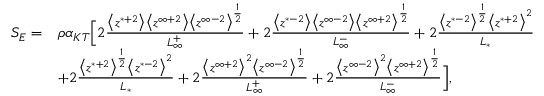<formula> <loc_0><loc_0><loc_500><loc_500>\begin{array} { r l } { S _ { E } = } & { \rho \alpha _ { K T } \left [ 2 \frac { \Big < z ^ { * + 2 } \Big > \Big < z ^ { \infty + 2 } \Big > \Big < z ^ { \infty - 2 } \Big > ^ { \frac { 1 } { 2 } } } { L _ { \infty } ^ { + } } + 2 \frac { \Big < z ^ { * - 2 } \Big > \Big < z ^ { \infty - 2 } \Big > \Big < z ^ { \infty + 2 } \Big > ^ { \frac { 1 } { 2 } } } { L _ { \infty } ^ { - } } + 2 \frac { \Big < z ^ { * - 2 } \Big > ^ { \frac { 1 } { 2 } } \Big < z ^ { * + 2 } \Big > ^ { 2 } } { L _ { * } } } \\ & { + 2 \frac { \Big < z ^ { * + 2 } \Big > ^ { \frac { 1 } { 2 } } \Big < z ^ { * - 2 } \Big > ^ { 2 } } { L _ { * } } + 2 \frac { \Big < z ^ { \infty + 2 } \Big > ^ { 2 } \Big < z ^ { \infty - 2 } \Big > ^ { \frac { 1 } { 2 } } } { L _ { \infty } ^ { + } } + 2 \frac { \Big < z ^ { \infty - 2 } \Big > ^ { 2 } \Big < z ^ { \infty + 2 } \Big > ^ { \frac { 1 } { 2 } } } { L _ { \infty } ^ { - } } \right ] , } \end{array}</formula> 